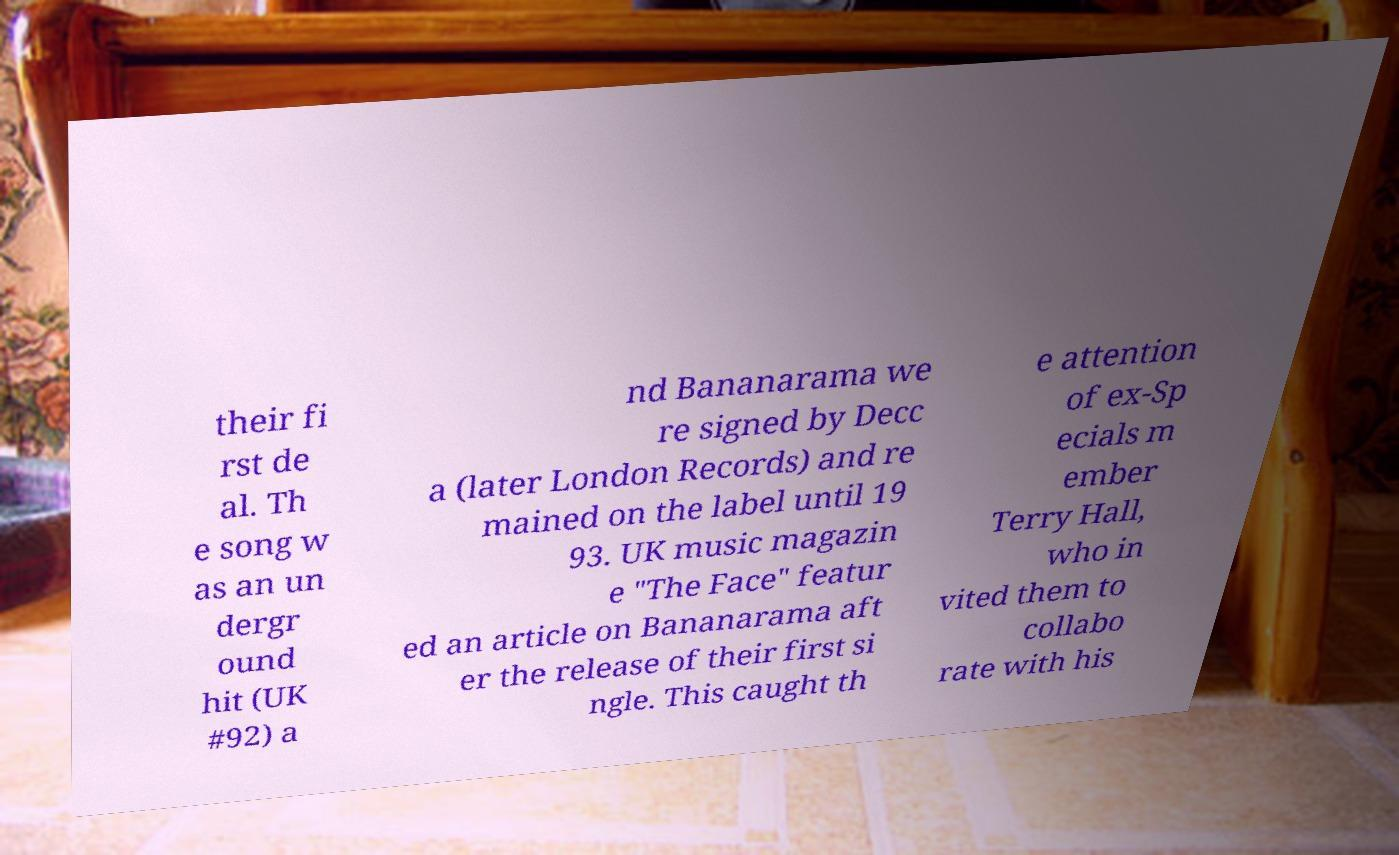Can you read and provide the text displayed in the image?This photo seems to have some interesting text. Can you extract and type it out for me? their fi rst de al. Th e song w as an un dergr ound hit (UK #92) a nd Bananarama we re signed by Decc a (later London Records) and re mained on the label until 19 93. UK music magazin e "The Face" featur ed an article on Bananarama aft er the release of their first si ngle. This caught th e attention of ex-Sp ecials m ember Terry Hall, who in vited them to collabo rate with his 